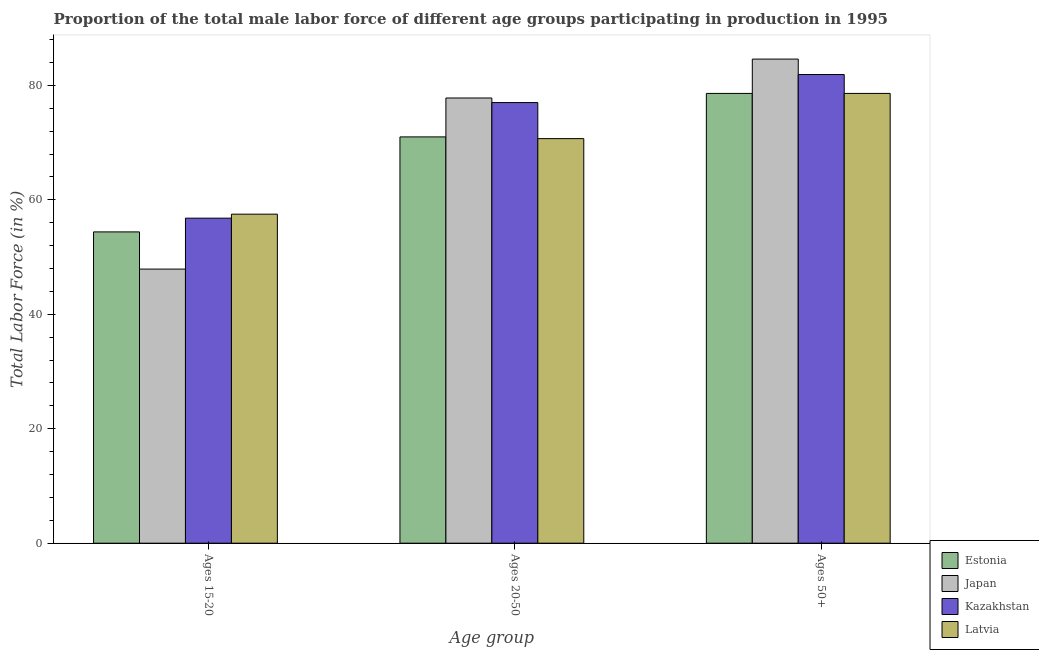How many different coloured bars are there?
Give a very brief answer. 4. Are the number of bars on each tick of the X-axis equal?
Give a very brief answer. Yes. What is the label of the 3rd group of bars from the left?
Keep it short and to the point. Ages 50+. What is the percentage of male labor force within the age group 15-20 in Estonia?
Keep it short and to the point. 54.4. Across all countries, what is the maximum percentage of male labor force within the age group 20-50?
Keep it short and to the point. 77.8. Across all countries, what is the minimum percentage of male labor force within the age group 15-20?
Provide a short and direct response. 47.9. In which country was the percentage of male labor force within the age group 15-20 maximum?
Keep it short and to the point. Latvia. In which country was the percentage of male labor force above age 50 minimum?
Your answer should be compact. Estonia. What is the total percentage of male labor force above age 50 in the graph?
Keep it short and to the point. 323.7. What is the difference between the percentage of male labor force within the age group 20-50 in Kazakhstan and that in Estonia?
Your answer should be very brief. 6. What is the difference between the percentage of male labor force above age 50 in Latvia and the percentage of male labor force within the age group 15-20 in Japan?
Provide a short and direct response. 30.7. What is the average percentage of male labor force above age 50 per country?
Keep it short and to the point. 80.92. What is the difference between the percentage of male labor force within the age group 15-20 and percentage of male labor force above age 50 in Latvia?
Your response must be concise. -21.1. In how many countries, is the percentage of male labor force within the age group 15-20 greater than 72 %?
Provide a short and direct response. 0. What is the ratio of the percentage of male labor force within the age group 15-20 in Kazakhstan to that in Japan?
Your answer should be very brief. 1.19. Is the percentage of male labor force above age 50 in Estonia less than that in Latvia?
Your answer should be very brief. No. Is the difference between the percentage of male labor force within the age group 20-50 in Estonia and Japan greater than the difference between the percentage of male labor force within the age group 15-20 in Estonia and Japan?
Make the answer very short. No. What is the difference between the highest and the second highest percentage of male labor force above age 50?
Your answer should be very brief. 2.7. What is the difference between the highest and the lowest percentage of male labor force within the age group 15-20?
Your answer should be very brief. 9.6. In how many countries, is the percentage of male labor force above age 50 greater than the average percentage of male labor force above age 50 taken over all countries?
Make the answer very short. 2. What does the 4th bar from the left in Ages 50+ represents?
Keep it short and to the point. Latvia. What does the 3rd bar from the right in Ages 20-50 represents?
Your answer should be very brief. Japan. Is it the case that in every country, the sum of the percentage of male labor force within the age group 15-20 and percentage of male labor force within the age group 20-50 is greater than the percentage of male labor force above age 50?
Provide a succinct answer. Yes. Are the values on the major ticks of Y-axis written in scientific E-notation?
Your response must be concise. No. Does the graph contain any zero values?
Ensure brevity in your answer.  No. What is the title of the graph?
Ensure brevity in your answer.  Proportion of the total male labor force of different age groups participating in production in 1995. Does "Tanzania" appear as one of the legend labels in the graph?
Your answer should be compact. No. What is the label or title of the X-axis?
Keep it short and to the point. Age group. What is the Total Labor Force (in %) of Estonia in Ages 15-20?
Keep it short and to the point. 54.4. What is the Total Labor Force (in %) in Japan in Ages 15-20?
Ensure brevity in your answer.  47.9. What is the Total Labor Force (in %) in Kazakhstan in Ages 15-20?
Give a very brief answer. 56.8. What is the Total Labor Force (in %) in Latvia in Ages 15-20?
Your answer should be compact. 57.5. What is the Total Labor Force (in %) in Estonia in Ages 20-50?
Your answer should be very brief. 71. What is the Total Labor Force (in %) in Japan in Ages 20-50?
Your answer should be compact. 77.8. What is the Total Labor Force (in %) of Kazakhstan in Ages 20-50?
Your response must be concise. 77. What is the Total Labor Force (in %) of Latvia in Ages 20-50?
Your answer should be compact. 70.7. What is the Total Labor Force (in %) in Estonia in Ages 50+?
Provide a short and direct response. 78.6. What is the Total Labor Force (in %) in Japan in Ages 50+?
Make the answer very short. 84.6. What is the Total Labor Force (in %) in Kazakhstan in Ages 50+?
Provide a succinct answer. 81.9. What is the Total Labor Force (in %) in Latvia in Ages 50+?
Provide a short and direct response. 78.6. Across all Age group, what is the maximum Total Labor Force (in %) of Estonia?
Your answer should be compact. 78.6. Across all Age group, what is the maximum Total Labor Force (in %) in Japan?
Give a very brief answer. 84.6. Across all Age group, what is the maximum Total Labor Force (in %) of Kazakhstan?
Offer a terse response. 81.9. Across all Age group, what is the maximum Total Labor Force (in %) of Latvia?
Offer a very short reply. 78.6. Across all Age group, what is the minimum Total Labor Force (in %) in Estonia?
Offer a terse response. 54.4. Across all Age group, what is the minimum Total Labor Force (in %) of Japan?
Offer a very short reply. 47.9. Across all Age group, what is the minimum Total Labor Force (in %) in Kazakhstan?
Your answer should be compact. 56.8. Across all Age group, what is the minimum Total Labor Force (in %) in Latvia?
Your response must be concise. 57.5. What is the total Total Labor Force (in %) in Estonia in the graph?
Provide a succinct answer. 204. What is the total Total Labor Force (in %) of Japan in the graph?
Provide a short and direct response. 210.3. What is the total Total Labor Force (in %) in Kazakhstan in the graph?
Offer a terse response. 215.7. What is the total Total Labor Force (in %) in Latvia in the graph?
Your answer should be compact. 206.8. What is the difference between the Total Labor Force (in %) in Estonia in Ages 15-20 and that in Ages 20-50?
Your answer should be very brief. -16.6. What is the difference between the Total Labor Force (in %) of Japan in Ages 15-20 and that in Ages 20-50?
Offer a very short reply. -29.9. What is the difference between the Total Labor Force (in %) in Kazakhstan in Ages 15-20 and that in Ages 20-50?
Your answer should be compact. -20.2. What is the difference between the Total Labor Force (in %) of Estonia in Ages 15-20 and that in Ages 50+?
Keep it short and to the point. -24.2. What is the difference between the Total Labor Force (in %) in Japan in Ages 15-20 and that in Ages 50+?
Offer a very short reply. -36.7. What is the difference between the Total Labor Force (in %) of Kazakhstan in Ages 15-20 and that in Ages 50+?
Ensure brevity in your answer.  -25.1. What is the difference between the Total Labor Force (in %) of Latvia in Ages 15-20 and that in Ages 50+?
Offer a terse response. -21.1. What is the difference between the Total Labor Force (in %) in Kazakhstan in Ages 20-50 and that in Ages 50+?
Offer a very short reply. -4.9. What is the difference between the Total Labor Force (in %) in Estonia in Ages 15-20 and the Total Labor Force (in %) in Japan in Ages 20-50?
Make the answer very short. -23.4. What is the difference between the Total Labor Force (in %) of Estonia in Ages 15-20 and the Total Labor Force (in %) of Kazakhstan in Ages 20-50?
Provide a short and direct response. -22.6. What is the difference between the Total Labor Force (in %) in Estonia in Ages 15-20 and the Total Labor Force (in %) in Latvia in Ages 20-50?
Your answer should be compact. -16.3. What is the difference between the Total Labor Force (in %) in Japan in Ages 15-20 and the Total Labor Force (in %) in Kazakhstan in Ages 20-50?
Make the answer very short. -29.1. What is the difference between the Total Labor Force (in %) of Japan in Ages 15-20 and the Total Labor Force (in %) of Latvia in Ages 20-50?
Ensure brevity in your answer.  -22.8. What is the difference between the Total Labor Force (in %) in Estonia in Ages 15-20 and the Total Labor Force (in %) in Japan in Ages 50+?
Offer a very short reply. -30.2. What is the difference between the Total Labor Force (in %) of Estonia in Ages 15-20 and the Total Labor Force (in %) of Kazakhstan in Ages 50+?
Offer a terse response. -27.5. What is the difference between the Total Labor Force (in %) of Estonia in Ages 15-20 and the Total Labor Force (in %) of Latvia in Ages 50+?
Ensure brevity in your answer.  -24.2. What is the difference between the Total Labor Force (in %) in Japan in Ages 15-20 and the Total Labor Force (in %) in Kazakhstan in Ages 50+?
Offer a very short reply. -34. What is the difference between the Total Labor Force (in %) in Japan in Ages 15-20 and the Total Labor Force (in %) in Latvia in Ages 50+?
Provide a short and direct response. -30.7. What is the difference between the Total Labor Force (in %) in Kazakhstan in Ages 15-20 and the Total Labor Force (in %) in Latvia in Ages 50+?
Keep it short and to the point. -21.8. What is the difference between the Total Labor Force (in %) in Estonia in Ages 20-50 and the Total Labor Force (in %) in Japan in Ages 50+?
Your answer should be very brief. -13.6. What is the difference between the Total Labor Force (in %) in Estonia in Ages 20-50 and the Total Labor Force (in %) in Kazakhstan in Ages 50+?
Your response must be concise. -10.9. What is the difference between the Total Labor Force (in %) of Estonia in Ages 20-50 and the Total Labor Force (in %) of Latvia in Ages 50+?
Provide a succinct answer. -7.6. What is the difference between the Total Labor Force (in %) of Kazakhstan in Ages 20-50 and the Total Labor Force (in %) of Latvia in Ages 50+?
Ensure brevity in your answer.  -1.6. What is the average Total Labor Force (in %) in Japan per Age group?
Offer a very short reply. 70.1. What is the average Total Labor Force (in %) in Kazakhstan per Age group?
Provide a succinct answer. 71.9. What is the average Total Labor Force (in %) in Latvia per Age group?
Give a very brief answer. 68.93. What is the difference between the Total Labor Force (in %) in Estonia and Total Labor Force (in %) in Japan in Ages 15-20?
Offer a terse response. 6.5. What is the difference between the Total Labor Force (in %) in Estonia and Total Labor Force (in %) in Latvia in Ages 15-20?
Make the answer very short. -3.1. What is the difference between the Total Labor Force (in %) of Japan and Total Labor Force (in %) of Kazakhstan in Ages 15-20?
Offer a terse response. -8.9. What is the difference between the Total Labor Force (in %) in Japan and Total Labor Force (in %) in Latvia in Ages 15-20?
Make the answer very short. -9.6. What is the difference between the Total Labor Force (in %) of Estonia and Total Labor Force (in %) of Kazakhstan in Ages 20-50?
Make the answer very short. -6. What is the difference between the Total Labor Force (in %) of Estonia and Total Labor Force (in %) of Latvia in Ages 20-50?
Provide a succinct answer. 0.3. What is the difference between the Total Labor Force (in %) of Japan and Total Labor Force (in %) of Kazakhstan in Ages 20-50?
Offer a terse response. 0.8. What is the difference between the Total Labor Force (in %) in Kazakhstan and Total Labor Force (in %) in Latvia in Ages 20-50?
Offer a very short reply. 6.3. What is the difference between the Total Labor Force (in %) of Estonia and Total Labor Force (in %) of Japan in Ages 50+?
Ensure brevity in your answer.  -6. What is the difference between the Total Labor Force (in %) in Estonia and Total Labor Force (in %) in Kazakhstan in Ages 50+?
Offer a terse response. -3.3. What is the difference between the Total Labor Force (in %) of Estonia and Total Labor Force (in %) of Latvia in Ages 50+?
Your answer should be very brief. 0. What is the difference between the Total Labor Force (in %) in Japan and Total Labor Force (in %) in Kazakhstan in Ages 50+?
Your response must be concise. 2.7. What is the difference between the Total Labor Force (in %) in Kazakhstan and Total Labor Force (in %) in Latvia in Ages 50+?
Keep it short and to the point. 3.3. What is the ratio of the Total Labor Force (in %) of Estonia in Ages 15-20 to that in Ages 20-50?
Provide a short and direct response. 0.77. What is the ratio of the Total Labor Force (in %) of Japan in Ages 15-20 to that in Ages 20-50?
Ensure brevity in your answer.  0.62. What is the ratio of the Total Labor Force (in %) of Kazakhstan in Ages 15-20 to that in Ages 20-50?
Give a very brief answer. 0.74. What is the ratio of the Total Labor Force (in %) in Latvia in Ages 15-20 to that in Ages 20-50?
Make the answer very short. 0.81. What is the ratio of the Total Labor Force (in %) in Estonia in Ages 15-20 to that in Ages 50+?
Offer a terse response. 0.69. What is the ratio of the Total Labor Force (in %) of Japan in Ages 15-20 to that in Ages 50+?
Your response must be concise. 0.57. What is the ratio of the Total Labor Force (in %) of Kazakhstan in Ages 15-20 to that in Ages 50+?
Offer a very short reply. 0.69. What is the ratio of the Total Labor Force (in %) in Latvia in Ages 15-20 to that in Ages 50+?
Make the answer very short. 0.73. What is the ratio of the Total Labor Force (in %) of Estonia in Ages 20-50 to that in Ages 50+?
Your answer should be very brief. 0.9. What is the ratio of the Total Labor Force (in %) in Japan in Ages 20-50 to that in Ages 50+?
Your answer should be very brief. 0.92. What is the ratio of the Total Labor Force (in %) in Kazakhstan in Ages 20-50 to that in Ages 50+?
Ensure brevity in your answer.  0.94. What is the ratio of the Total Labor Force (in %) of Latvia in Ages 20-50 to that in Ages 50+?
Ensure brevity in your answer.  0.9. What is the difference between the highest and the lowest Total Labor Force (in %) in Estonia?
Your response must be concise. 24.2. What is the difference between the highest and the lowest Total Labor Force (in %) in Japan?
Offer a very short reply. 36.7. What is the difference between the highest and the lowest Total Labor Force (in %) of Kazakhstan?
Provide a short and direct response. 25.1. What is the difference between the highest and the lowest Total Labor Force (in %) in Latvia?
Your answer should be compact. 21.1. 